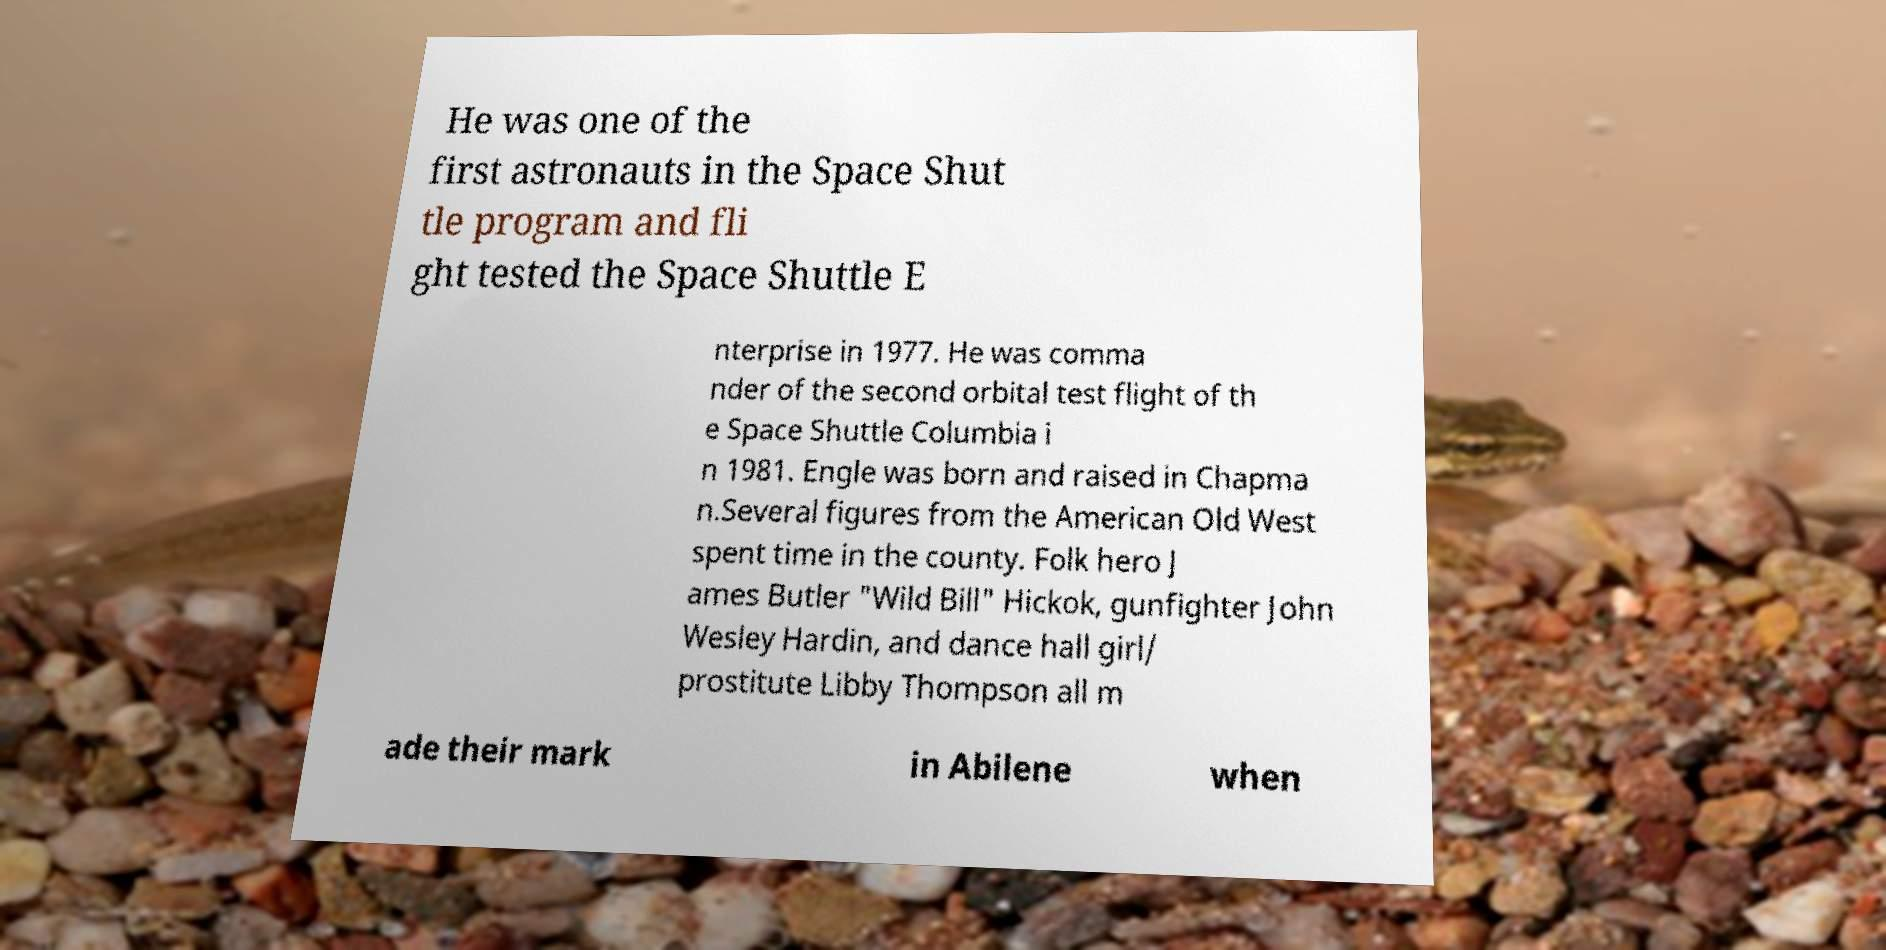For documentation purposes, I need the text within this image transcribed. Could you provide that? He was one of the first astronauts in the Space Shut tle program and fli ght tested the Space Shuttle E nterprise in 1977. He was comma nder of the second orbital test flight of th e Space Shuttle Columbia i n 1981. Engle was born and raised in Chapma n.Several figures from the American Old West spent time in the county. Folk hero J ames Butler "Wild Bill" Hickok, gunfighter John Wesley Hardin, and dance hall girl/ prostitute Libby Thompson all m ade their mark in Abilene when 